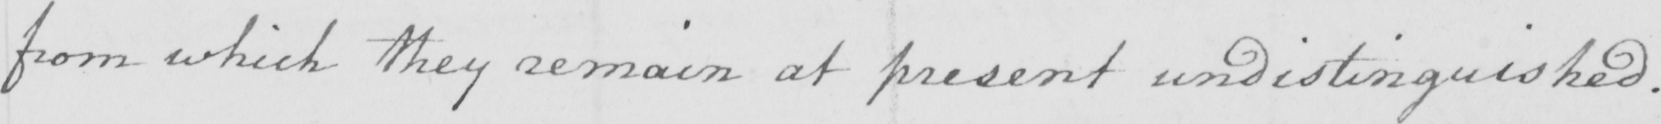What is written in this line of handwriting? from which they remain at present undistinguished . 